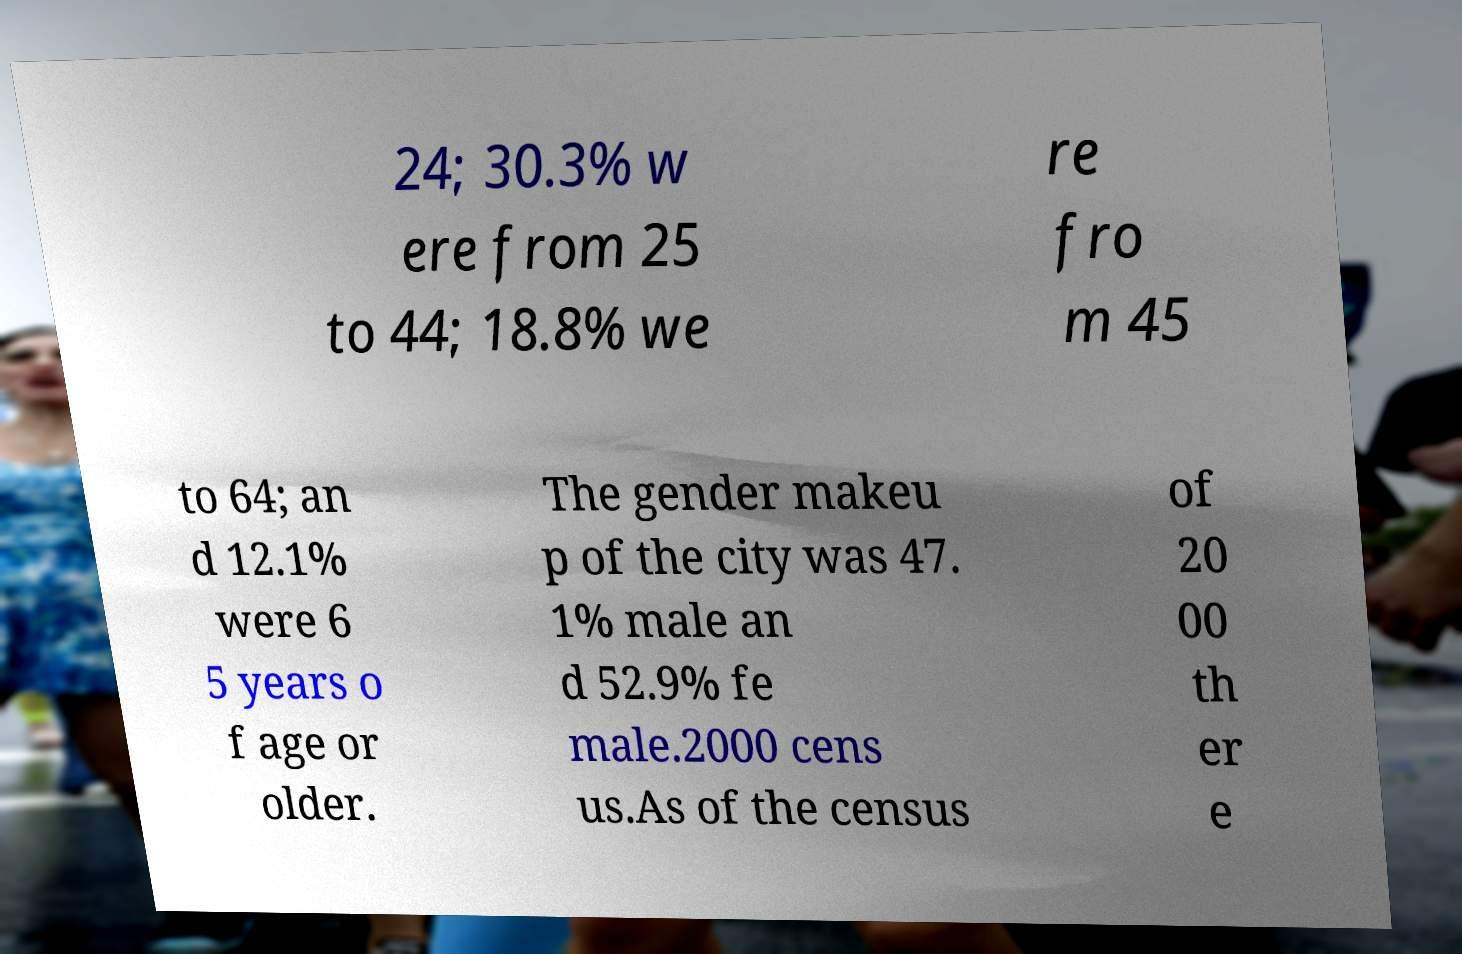There's text embedded in this image that I need extracted. Can you transcribe it verbatim? 24; 30.3% w ere from 25 to 44; 18.8% we re fro m 45 to 64; an d 12.1% were 6 5 years o f age or older. The gender makeu p of the city was 47. 1% male an d 52.9% fe male.2000 cens us.As of the census of 20 00 th er e 